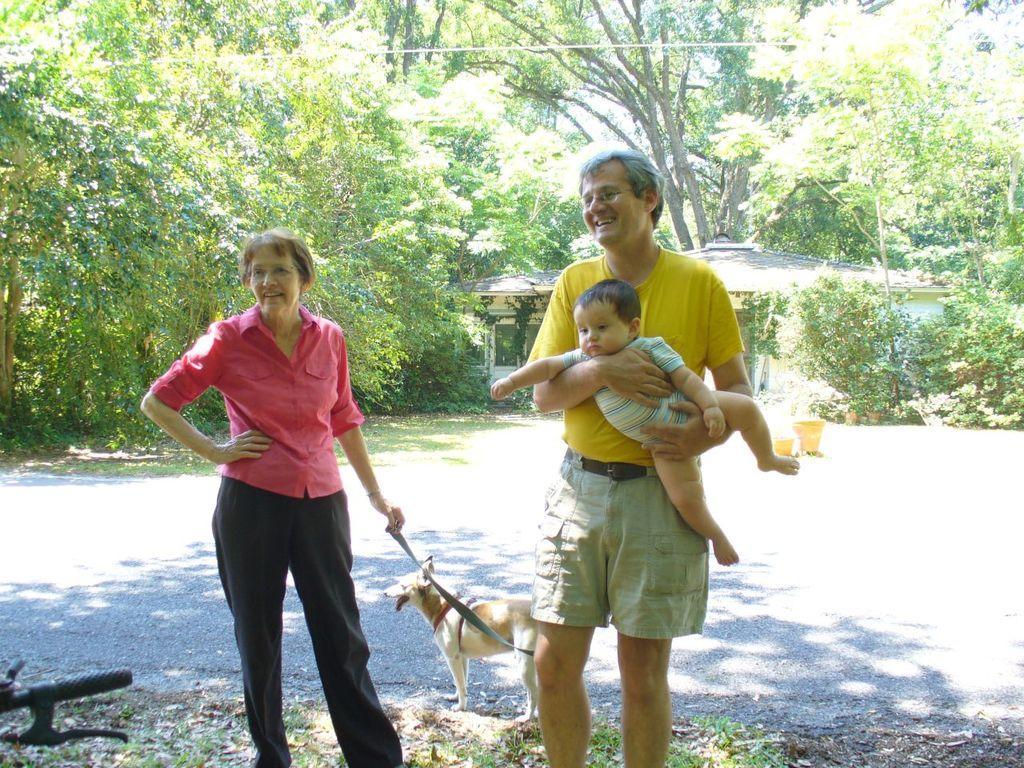Can you describe this image briefly? In this image, In the middle there is a man standing and holding a kid, In the left side there is a woman standing and she is holding a dog, In the background there are some green color trees. 